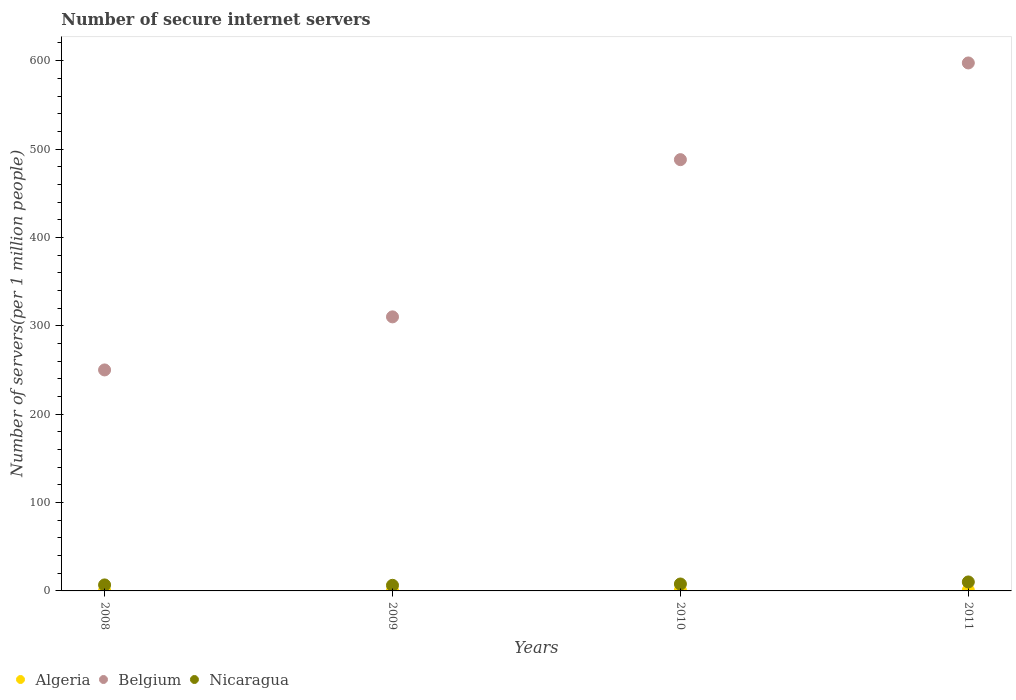What is the number of secure internet servers in Nicaragua in 2010?
Offer a terse response. 7.84. Across all years, what is the maximum number of secure internet servers in Nicaragua?
Offer a very short reply. 10.16. Across all years, what is the minimum number of secure internet servers in Nicaragua?
Make the answer very short. 6.35. What is the total number of secure internet servers in Belgium in the graph?
Provide a succinct answer. 1645.55. What is the difference between the number of secure internet servers in Belgium in 2008 and that in 2010?
Ensure brevity in your answer.  -237.94. What is the difference between the number of secure internet servers in Algeria in 2011 and the number of secure internet servers in Belgium in 2008?
Provide a short and direct response. -249.12. What is the average number of secure internet servers in Nicaragua per year?
Give a very brief answer. 7.79. In the year 2010, what is the difference between the number of secure internet servers in Belgium and number of secure internet servers in Algeria?
Make the answer very short. 487.13. What is the ratio of the number of secure internet servers in Algeria in 2009 to that in 2011?
Offer a very short reply. 0.58. Is the number of secure internet servers in Algeria in 2009 less than that in 2011?
Your answer should be compact. Yes. What is the difference between the highest and the second highest number of secure internet servers in Nicaragua?
Offer a terse response. 2.32. What is the difference between the highest and the lowest number of secure internet servers in Belgium?
Your response must be concise. 347.36. Is it the case that in every year, the sum of the number of secure internet servers in Belgium and number of secure internet servers in Algeria  is greater than the number of secure internet servers in Nicaragua?
Give a very brief answer. Yes. Does the number of secure internet servers in Nicaragua monotonically increase over the years?
Keep it short and to the point. No. Is the number of secure internet servers in Nicaragua strictly less than the number of secure internet servers in Algeria over the years?
Provide a short and direct response. No. How many years are there in the graph?
Your answer should be very brief. 4. Where does the legend appear in the graph?
Ensure brevity in your answer.  Bottom left. How many legend labels are there?
Offer a very short reply. 3. How are the legend labels stacked?
Your answer should be compact. Horizontal. What is the title of the graph?
Provide a succinct answer. Number of secure internet servers. Does "Kenya" appear as one of the legend labels in the graph?
Give a very brief answer. No. What is the label or title of the Y-axis?
Offer a terse response. Number of servers(per 1 million people). What is the Number of servers(per 1 million people) in Algeria in 2008?
Keep it short and to the point. 0.52. What is the Number of servers(per 1 million people) of Belgium in 2008?
Your answer should be very brief. 250.05. What is the Number of servers(per 1 million people) in Nicaragua in 2008?
Ensure brevity in your answer.  6.79. What is the Number of servers(per 1 million people) of Algeria in 2009?
Keep it short and to the point. 0.54. What is the Number of servers(per 1 million people) of Belgium in 2009?
Give a very brief answer. 310.1. What is the Number of servers(per 1 million people) in Nicaragua in 2009?
Keep it short and to the point. 6.35. What is the Number of servers(per 1 million people) in Algeria in 2010?
Ensure brevity in your answer.  0.86. What is the Number of servers(per 1 million people) in Belgium in 2010?
Provide a succinct answer. 487.99. What is the Number of servers(per 1 million people) of Nicaragua in 2010?
Your answer should be compact. 7.84. What is the Number of servers(per 1 million people) of Algeria in 2011?
Your answer should be very brief. 0.93. What is the Number of servers(per 1 million people) in Belgium in 2011?
Provide a short and direct response. 597.41. What is the Number of servers(per 1 million people) in Nicaragua in 2011?
Keep it short and to the point. 10.16. Across all years, what is the maximum Number of servers(per 1 million people) in Algeria?
Provide a short and direct response. 0.93. Across all years, what is the maximum Number of servers(per 1 million people) in Belgium?
Provide a succinct answer. 597.41. Across all years, what is the maximum Number of servers(per 1 million people) of Nicaragua?
Make the answer very short. 10.16. Across all years, what is the minimum Number of servers(per 1 million people) in Algeria?
Ensure brevity in your answer.  0.52. Across all years, what is the minimum Number of servers(per 1 million people) of Belgium?
Offer a very short reply. 250.05. Across all years, what is the minimum Number of servers(per 1 million people) in Nicaragua?
Make the answer very short. 6.35. What is the total Number of servers(per 1 million people) in Algeria in the graph?
Your answer should be compact. 2.84. What is the total Number of servers(per 1 million people) in Belgium in the graph?
Provide a short and direct response. 1645.55. What is the total Number of servers(per 1 million people) of Nicaragua in the graph?
Provide a short and direct response. 31.15. What is the difference between the Number of servers(per 1 million people) of Algeria in 2008 and that in 2009?
Provide a short and direct response. -0.02. What is the difference between the Number of servers(per 1 million people) of Belgium in 2008 and that in 2009?
Your response must be concise. -60.05. What is the difference between the Number of servers(per 1 million people) in Nicaragua in 2008 and that in 2009?
Offer a terse response. 0.44. What is the difference between the Number of servers(per 1 million people) of Algeria in 2008 and that in 2010?
Offer a terse response. -0.34. What is the difference between the Number of servers(per 1 million people) of Belgium in 2008 and that in 2010?
Provide a short and direct response. -237.94. What is the difference between the Number of servers(per 1 million people) in Nicaragua in 2008 and that in 2010?
Your answer should be compact. -1.05. What is the difference between the Number of servers(per 1 million people) in Algeria in 2008 and that in 2011?
Keep it short and to the point. -0.41. What is the difference between the Number of servers(per 1 million people) in Belgium in 2008 and that in 2011?
Provide a short and direct response. -347.36. What is the difference between the Number of servers(per 1 million people) in Nicaragua in 2008 and that in 2011?
Your response must be concise. -3.37. What is the difference between the Number of servers(per 1 million people) of Algeria in 2009 and that in 2010?
Your answer should be compact. -0.32. What is the difference between the Number of servers(per 1 million people) in Belgium in 2009 and that in 2010?
Offer a very short reply. -177.89. What is the difference between the Number of servers(per 1 million people) of Nicaragua in 2009 and that in 2010?
Give a very brief answer. -1.49. What is the difference between the Number of servers(per 1 million people) of Algeria in 2009 and that in 2011?
Provide a short and direct response. -0.39. What is the difference between the Number of servers(per 1 million people) of Belgium in 2009 and that in 2011?
Your answer should be compact. -287.31. What is the difference between the Number of servers(per 1 million people) of Nicaragua in 2009 and that in 2011?
Make the answer very short. -3.81. What is the difference between the Number of servers(per 1 million people) of Algeria in 2010 and that in 2011?
Your response must be concise. -0.07. What is the difference between the Number of servers(per 1 million people) of Belgium in 2010 and that in 2011?
Provide a short and direct response. -109.42. What is the difference between the Number of servers(per 1 million people) of Nicaragua in 2010 and that in 2011?
Your answer should be compact. -2.32. What is the difference between the Number of servers(per 1 million people) in Algeria in 2008 and the Number of servers(per 1 million people) in Belgium in 2009?
Keep it short and to the point. -309.58. What is the difference between the Number of servers(per 1 million people) of Algeria in 2008 and the Number of servers(per 1 million people) of Nicaragua in 2009?
Your answer should be compact. -5.84. What is the difference between the Number of servers(per 1 million people) in Belgium in 2008 and the Number of servers(per 1 million people) in Nicaragua in 2009?
Your response must be concise. 243.69. What is the difference between the Number of servers(per 1 million people) in Algeria in 2008 and the Number of servers(per 1 million people) in Belgium in 2010?
Ensure brevity in your answer.  -487.47. What is the difference between the Number of servers(per 1 million people) in Algeria in 2008 and the Number of servers(per 1 million people) in Nicaragua in 2010?
Ensure brevity in your answer.  -7.33. What is the difference between the Number of servers(per 1 million people) in Belgium in 2008 and the Number of servers(per 1 million people) in Nicaragua in 2010?
Provide a short and direct response. 242.2. What is the difference between the Number of servers(per 1 million people) of Algeria in 2008 and the Number of servers(per 1 million people) of Belgium in 2011?
Offer a terse response. -596.89. What is the difference between the Number of servers(per 1 million people) of Algeria in 2008 and the Number of servers(per 1 million people) of Nicaragua in 2011?
Provide a succinct answer. -9.64. What is the difference between the Number of servers(per 1 million people) in Belgium in 2008 and the Number of servers(per 1 million people) in Nicaragua in 2011?
Make the answer very short. 239.89. What is the difference between the Number of servers(per 1 million people) in Algeria in 2009 and the Number of servers(per 1 million people) in Belgium in 2010?
Offer a terse response. -487.45. What is the difference between the Number of servers(per 1 million people) of Algeria in 2009 and the Number of servers(per 1 million people) of Nicaragua in 2010?
Give a very brief answer. -7.31. What is the difference between the Number of servers(per 1 million people) of Belgium in 2009 and the Number of servers(per 1 million people) of Nicaragua in 2010?
Your answer should be compact. 302.26. What is the difference between the Number of servers(per 1 million people) in Algeria in 2009 and the Number of servers(per 1 million people) in Belgium in 2011?
Provide a short and direct response. -596.87. What is the difference between the Number of servers(per 1 million people) in Algeria in 2009 and the Number of servers(per 1 million people) in Nicaragua in 2011?
Ensure brevity in your answer.  -9.62. What is the difference between the Number of servers(per 1 million people) of Belgium in 2009 and the Number of servers(per 1 million people) of Nicaragua in 2011?
Keep it short and to the point. 299.94. What is the difference between the Number of servers(per 1 million people) in Algeria in 2010 and the Number of servers(per 1 million people) in Belgium in 2011?
Your answer should be compact. -596.55. What is the difference between the Number of servers(per 1 million people) of Algeria in 2010 and the Number of servers(per 1 million people) of Nicaragua in 2011?
Your answer should be very brief. -9.3. What is the difference between the Number of servers(per 1 million people) of Belgium in 2010 and the Number of servers(per 1 million people) of Nicaragua in 2011?
Your answer should be very brief. 477.83. What is the average Number of servers(per 1 million people) of Algeria per year?
Your answer should be compact. 0.71. What is the average Number of servers(per 1 million people) of Belgium per year?
Your answer should be compact. 411.39. What is the average Number of servers(per 1 million people) of Nicaragua per year?
Your response must be concise. 7.79. In the year 2008, what is the difference between the Number of servers(per 1 million people) of Algeria and Number of servers(per 1 million people) of Belgium?
Your response must be concise. -249.53. In the year 2008, what is the difference between the Number of servers(per 1 million people) of Algeria and Number of servers(per 1 million people) of Nicaragua?
Give a very brief answer. -6.28. In the year 2008, what is the difference between the Number of servers(per 1 million people) of Belgium and Number of servers(per 1 million people) of Nicaragua?
Provide a succinct answer. 243.25. In the year 2009, what is the difference between the Number of servers(per 1 million people) of Algeria and Number of servers(per 1 million people) of Belgium?
Offer a very short reply. -309.56. In the year 2009, what is the difference between the Number of servers(per 1 million people) of Algeria and Number of servers(per 1 million people) of Nicaragua?
Make the answer very short. -5.82. In the year 2009, what is the difference between the Number of servers(per 1 million people) in Belgium and Number of servers(per 1 million people) in Nicaragua?
Give a very brief answer. 303.75. In the year 2010, what is the difference between the Number of servers(per 1 million people) in Algeria and Number of servers(per 1 million people) in Belgium?
Your response must be concise. -487.13. In the year 2010, what is the difference between the Number of servers(per 1 million people) of Algeria and Number of servers(per 1 million people) of Nicaragua?
Provide a succinct answer. -6.98. In the year 2010, what is the difference between the Number of servers(per 1 million people) of Belgium and Number of servers(per 1 million people) of Nicaragua?
Your answer should be very brief. 480.15. In the year 2011, what is the difference between the Number of servers(per 1 million people) of Algeria and Number of servers(per 1 million people) of Belgium?
Your response must be concise. -596.48. In the year 2011, what is the difference between the Number of servers(per 1 million people) in Algeria and Number of servers(per 1 million people) in Nicaragua?
Give a very brief answer. -9.23. In the year 2011, what is the difference between the Number of servers(per 1 million people) of Belgium and Number of servers(per 1 million people) of Nicaragua?
Provide a short and direct response. 587.25. What is the ratio of the Number of servers(per 1 million people) in Algeria in 2008 to that in 2009?
Provide a short and direct response. 0.96. What is the ratio of the Number of servers(per 1 million people) in Belgium in 2008 to that in 2009?
Offer a very short reply. 0.81. What is the ratio of the Number of servers(per 1 million people) in Nicaragua in 2008 to that in 2009?
Provide a short and direct response. 1.07. What is the ratio of the Number of servers(per 1 million people) of Algeria in 2008 to that in 2010?
Your answer should be compact. 0.6. What is the ratio of the Number of servers(per 1 million people) in Belgium in 2008 to that in 2010?
Your response must be concise. 0.51. What is the ratio of the Number of servers(per 1 million people) in Nicaragua in 2008 to that in 2010?
Your answer should be compact. 0.87. What is the ratio of the Number of servers(per 1 million people) of Algeria in 2008 to that in 2011?
Give a very brief answer. 0.56. What is the ratio of the Number of servers(per 1 million people) in Belgium in 2008 to that in 2011?
Provide a short and direct response. 0.42. What is the ratio of the Number of servers(per 1 million people) in Nicaragua in 2008 to that in 2011?
Your answer should be compact. 0.67. What is the ratio of the Number of servers(per 1 million people) in Algeria in 2009 to that in 2010?
Give a very brief answer. 0.62. What is the ratio of the Number of servers(per 1 million people) in Belgium in 2009 to that in 2010?
Your answer should be compact. 0.64. What is the ratio of the Number of servers(per 1 million people) in Nicaragua in 2009 to that in 2010?
Ensure brevity in your answer.  0.81. What is the ratio of the Number of servers(per 1 million people) in Algeria in 2009 to that in 2011?
Provide a short and direct response. 0.58. What is the ratio of the Number of servers(per 1 million people) in Belgium in 2009 to that in 2011?
Provide a succinct answer. 0.52. What is the ratio of the Number of servers(per 1 million people) of Nicaragua in 2009 to that in 2011?
Offer a very short reply. 0.63. What is the ratio of the Number of servers(per 1 million people) in Algeria in 2010 to that in 2011?
Your answer should be very brief. 0.93. What is the ratio of the Number of servers(per 1 million people) of Belgium in 2010 to that in 2011?
Provide a succinct answer. 0.82. What is the ratio of the Number of servers(per 1 million people) in Nicaragua in 2010 to that in 2011?
Make the answer very short. 0.77. What is the difference between the highest and the second highest Number of servers(per 1 million people) in Algeria?
Offer a terse response. 0.07. What is the difference between the highest and the second highest Number of servers(per 1 million people) of Belgium?
Provide a short and direct response. 109.42. What is the difference between the highest and the second highest Number of servers(per 1 million people) of Nicaragua?
Offer a terse response. 2.32. What is the difference between the highest and the lowest Number of servers(per 1 million people) in Algeria?
Ensure brevity in your answer.  0.41. What is the difference between the highest and the lowest Number of servers(per 1 million people) of Belgium?
Keep it short and to the point. 347.36. What is the difference between the highest and the lowest Number of servers(per 1 million people) of Nicaragua?
Your answer should be compact. 3.81. 